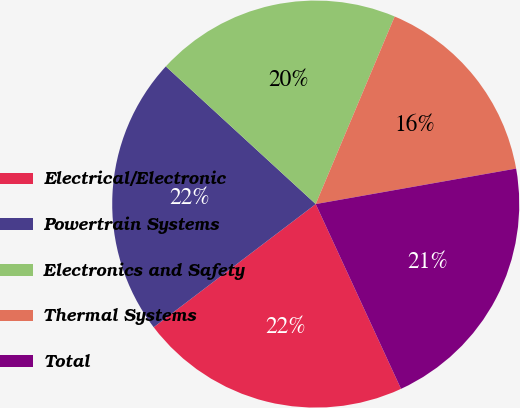Convert chart. <chart><loc_0><loc_0><loc_500><loc_500><pie_chart><fcel>Electrical/Electronic<fcel>Powertrain Systems<fcel>Electronics and Safety<fcel>Thermal Systems<fcel>Total<nl><fcel>21.54%<fcel>22.17%<fcel>19.52%<fcel>15.87%<fcel>20.91%<nl></chart> 